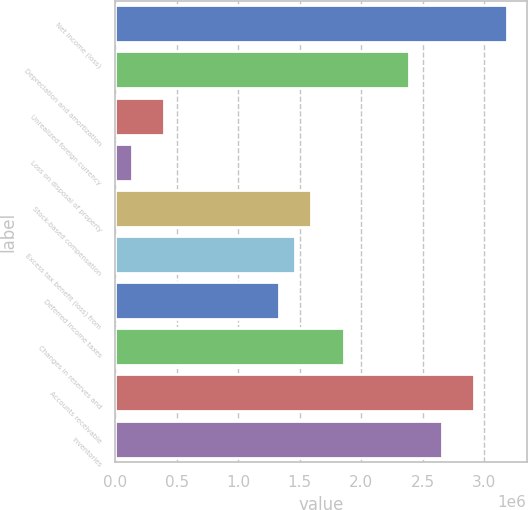<chart> <loc_0><loc_0><loc_500><loc_500><bar_chart><fcel>Net income (loss)<fcel>Depreciation and amortization<fcel>Unrealized foreign currency<fcel>Loss on disposal of property<fcel>Stock-based compensation<fcel>Excess tax benefit (loss) from<fcel>Deferred income taxes<fcel>Changes in reserves and<fcel>Accounts receivable<fcel>Inventories<nl><fcel>3.18502e+06<fcel>2.38898e+06<fcel>398893<fcel>133548<fcel>1.59295e+06<fcel>1.46027e+06<fcel>1.3276e+06<fcel>1.85829e+06<fcel>2.91967e+06<fcel>2.65433e+06<nl></chart> 